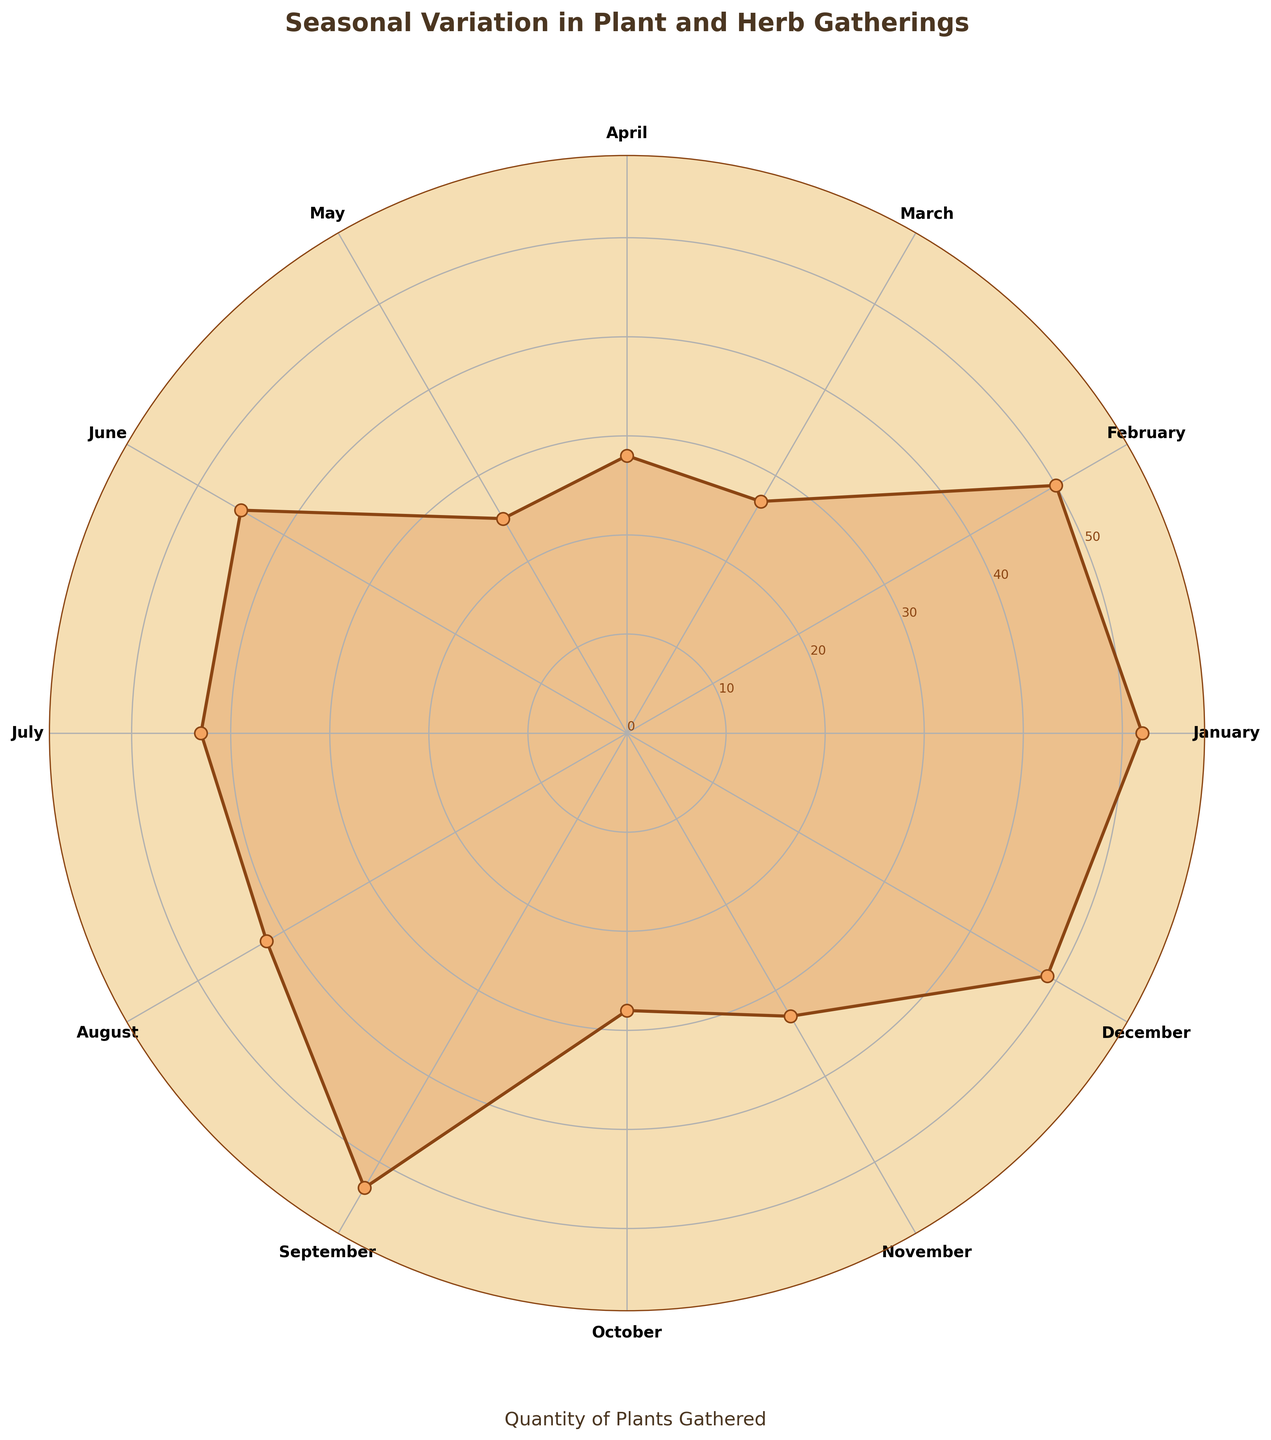What is the title of the chart? The title is located at the top of the chart, usually in bold letters. In this case, it is shown clearly as "Seasonal Variation in Plant and Herb Gatherings".
Answer: Seasonal Variation in Plant and Herb Gatherings How many data points are there in the chart? Each data point represents a month, and since there are 12 months in a year, there are 12 data points.
Answer: 12 What is the range of the y-axis values? The y-axis represents the quantities gathered. By observing the tick labels, the range is from 0 to the maximum value, with ticks at regular intervals of 10. The maximum value on the y-axis is the highest quantity, which is the sum of plant quantities gathered in one month.
Answer: 0 to 68 Which month has the highest quantity of plants gathered? By visually examining the peaks of the plot, the tallest point on the chart corresponds to May.
Answer: May How much more quantity of plants was gathered in May compared to January? In May, the total quantity is the sum of Alfalfa (35) and Burdock Root (18), which totals 53. In January, it is Echinacea (15) plus Ginseng (10), which totals 25. The difference is 53 - 25.
Answer: 28 In which month was the lowest quantity of plants gathered? By identifying the shortest point (closest to the center) on the chart, the lowest month appears to be January.
Answer: January Which season shows the greatest variation in plant gatherings? To determine variation, observe the spread of points within each season. Seasonal variations are typically highest in spring or summer. We sum the quantities for months in each season and compare them.
Answer: Spring What's the average quantity gathered per month? Summing the monthly quantities and dividing by the number of months (12) will yield the average. The sum is (15 + 10 + 20 + 8 + 25 + 17 + 30 + 22 + 35 + 18 + 28 + 15 + 20 + 25 + 32 + 18 + 27 + 22 + 13 + 20 + 10 + 18 + 12 + 15) which totals to 445. Dividing 445 by 12 gives 37.08.
Answer: 37.08 Which two months have the closest quantities of plants gathered? By comparing the quantities month-by-month, notice which two months have the smallest difference. March (42) and April (52) have a difference of 10.
Answer: March and April 